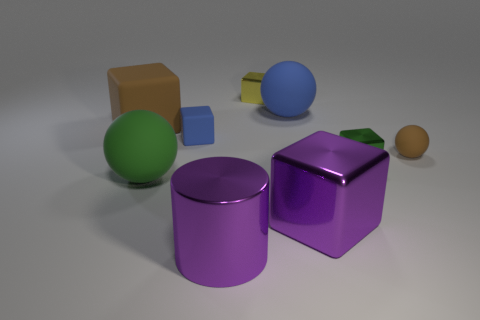What is the size of the yellow thing that is made of the same material as the cylinder?
Your answer should be compact. Small. Is the number of tiny brown matte balls that are in front of the large metallic cube greater than the number of big red metal cylinders?
Provide a succinct answer. No. What is the blue object that is to the right of the small shiny object that is to the left of the shiny block in front of the green rubber thing made of?
Give a very brief answer. Rubber. Does the small brown thing have the same material as the tiny object behind the large brown block?
Offer a terse response. No. What is the material of the small object that is the same shape as the big blue rubber object?
Offer a terse response. Rubber. Are there any other things that are made of the same material as the tiny blue object?
Your response must be concise. Yes. Is the number of tiny cubes to the left of the big green thing greater than the number of small blue objects that are behind the large purple shiny cylinder?
Offer a terse response. No. The yellow object that is made of the same material as the tiny green object is what shape?
Give a very brief answer. Cube. What number of other things are the same shape as the large green thing?
Ensure brevity in your answer.  2. What is the shape of the purple shiny thing that is left of the large blue rubber sphere?
Offer a very short reply. Cylinder. 